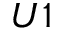Convert formula to latex. <formula><loc_0><loc_0><loc_500><loc_500>U 1</formula> 